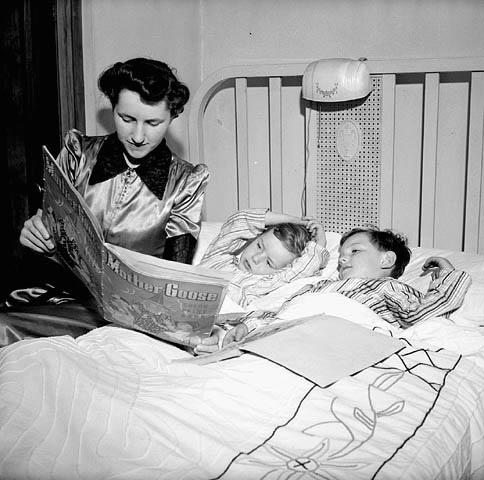Describe the objects in this image and their specific colors. I can see bed in black, gainsboro, darkgray, and gray tones, people in black, darkgray, gray, and lightgray tones, book in black, gray, darkgray, and lightgray tones, people in black, lightgray, darkgray, and gray tones, and people in black, lightgray, darkgray, and gray tones in this image. 